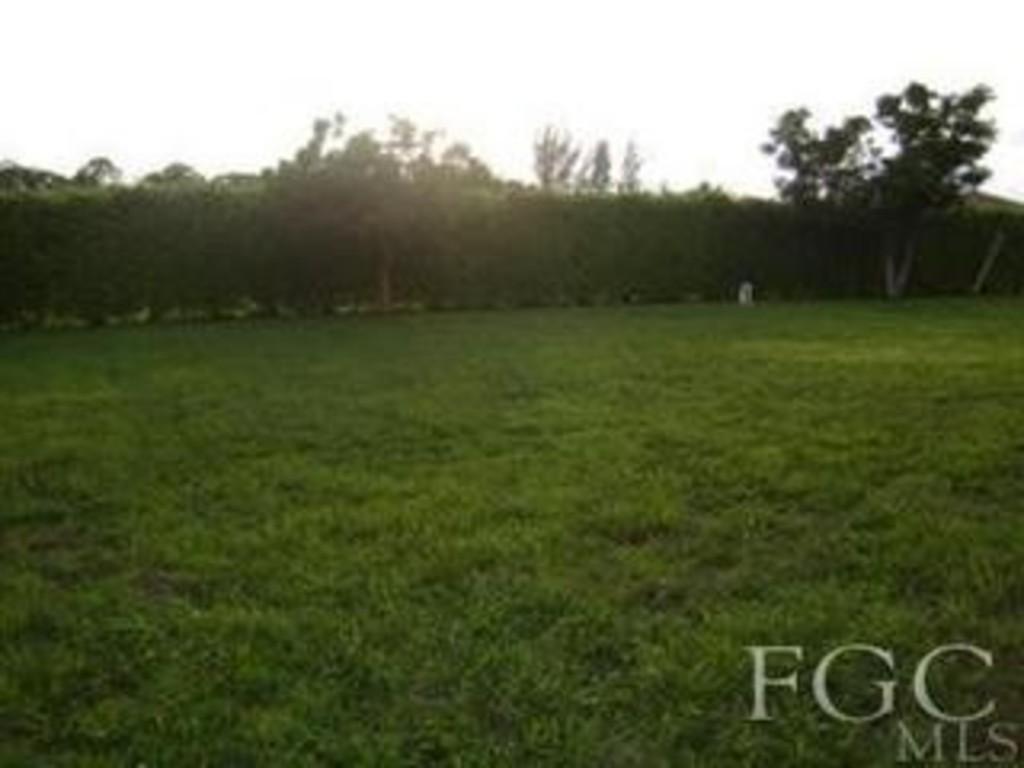Could you give a brief overview of what you see in this image? In this image there are trees on the grassland. Right bottom there is some text. Top of the image there is sky. 